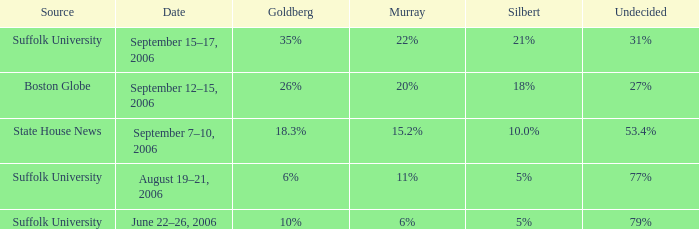On which date is the poll showing silbert at 1 September 7–10, 2006. 